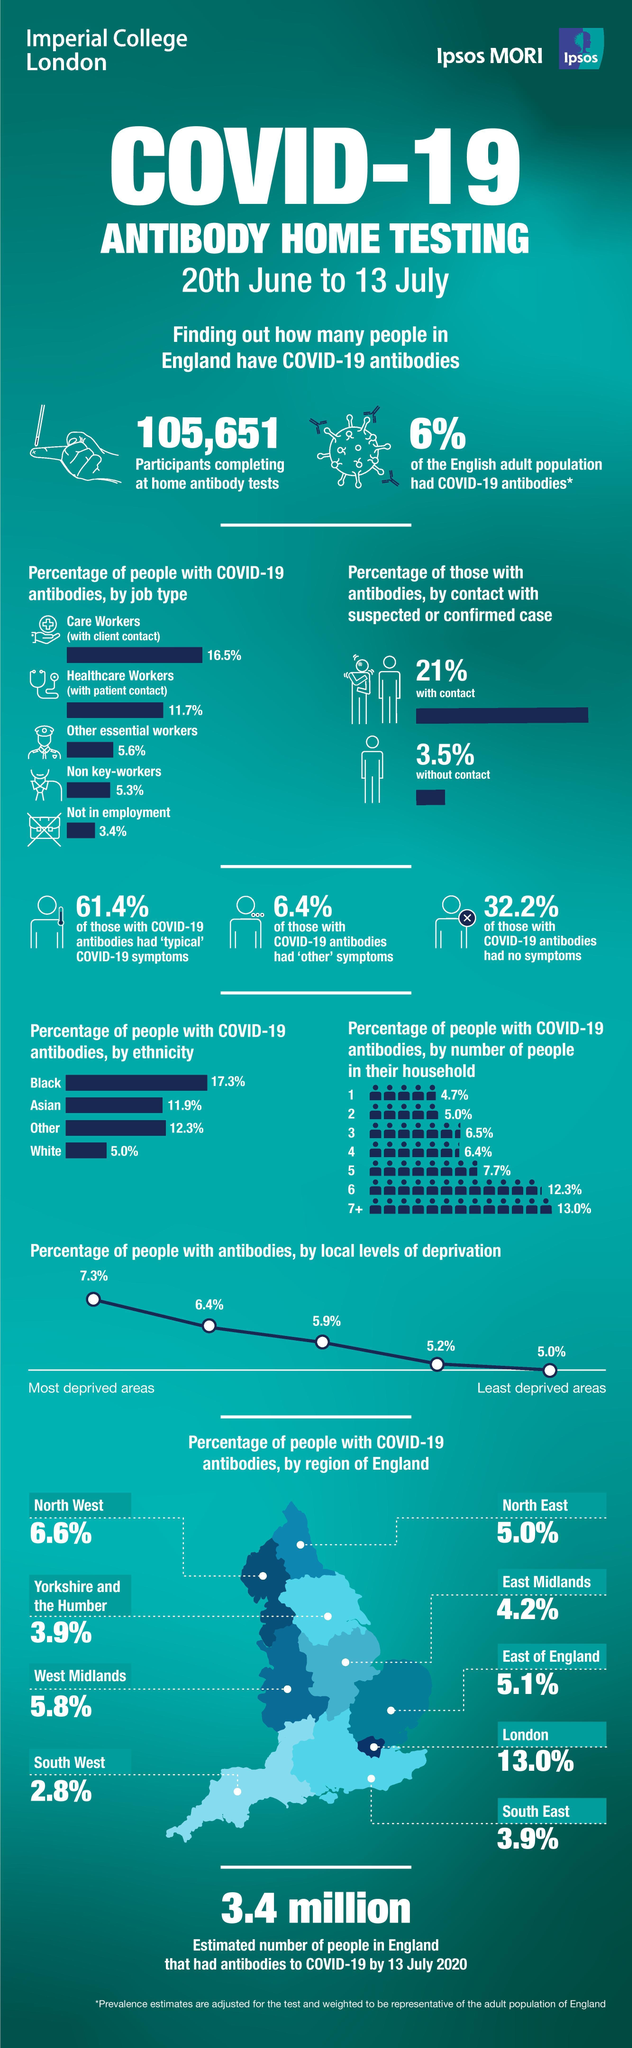what % of people with COVID-19 had no symptoms
Answer the question with a short phrase. 32.2 which region of England has the same % of people with COVID-19 antibodies as South East Yorkshire and the Humber what is the % difference of people with antibodies in most deprived areas when compared to least deprivded areas 2.3 what % of non key workers and care workers have COVID-19 antibodies 21.8 which region of England has the third lowest % of people with COVID-19 antibodies East Midlands what is the % of cases due to contact 21% which group as per ethnicity had the second highest infection rate Other 